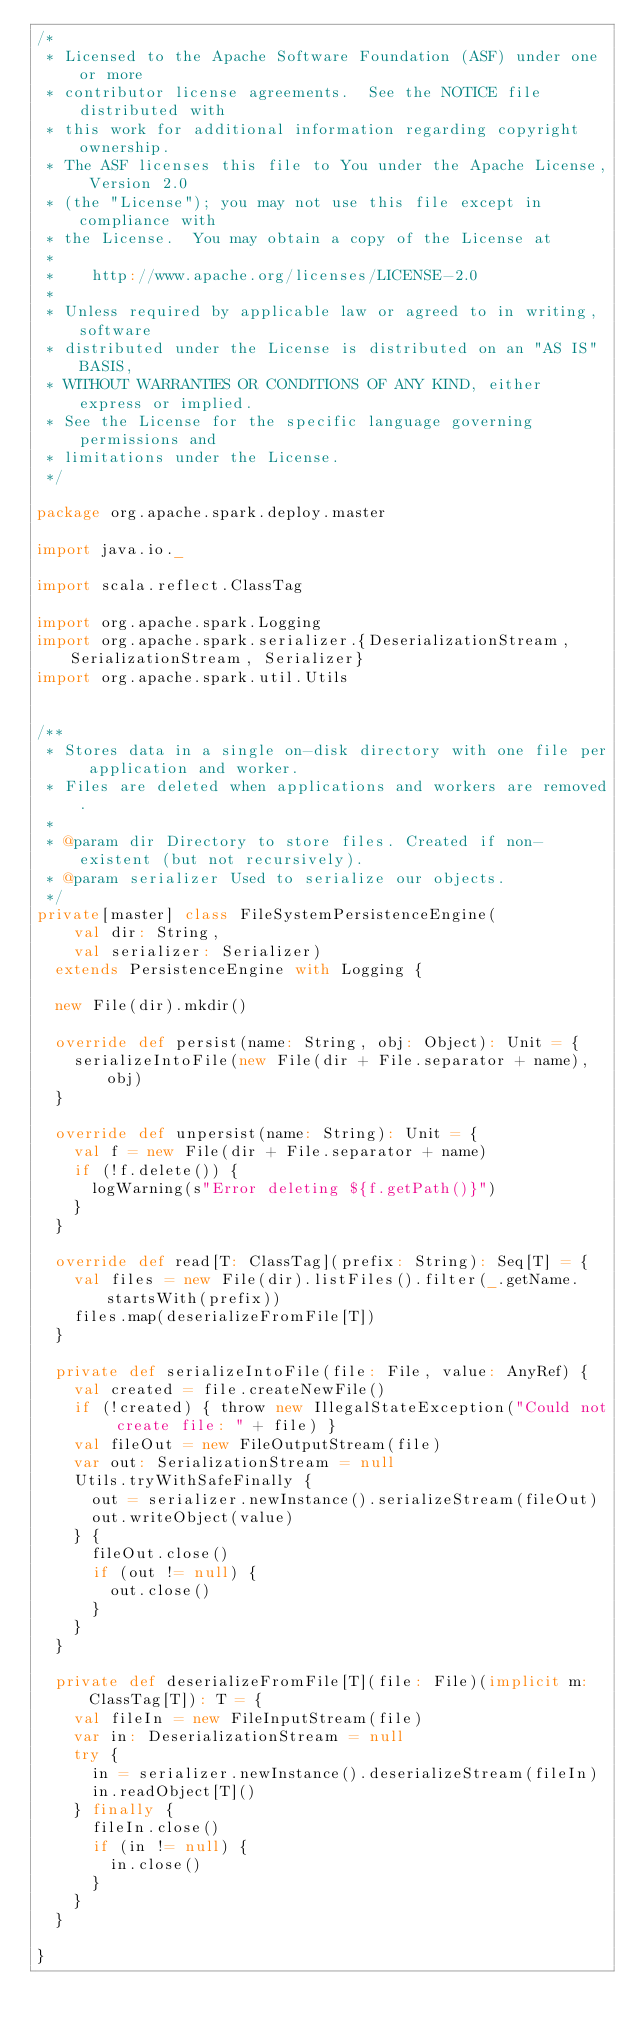Convert code to text. <code><loc_0><loc_0><loc_500><loc_500><_Scala_>/*
 * Licensed to the Apache Software Foundation (ASF) under one or more
 * contributor license agreements.  See the NOTICE file distributed with
 * this work for additional information regarding copyright ownership.
 * The ASF licenses this file to You under the Apache License, Version 2.0
 * (the "License"); you may not use this file except in compliance with
 * the License.  You may obtain a copy of the License at
 *
 *    http://www.apache.org/licenses/LICENSE-2.0
 *
 * Unless required by applicable law or agreed to in writing, software
 * distributed under the License is distributed on an "AS IS" BASIS,
 * WITHOUT WARRANTIES OR CONDITIONS OF ANY KIND, either express or implied.
 * See the License for the specific language governing permissions and
 * limitations under the License.
 */

package org.apache.spark.deploy.master

import java.io._

import scala.reflect.ClassTag

import org.apache.spark.Logging
import org.apache.spark.serializer.{DeserializationStream, SerializationStream, Serializer}
import org.apache.spark.util.Utils


/**
 * Stores data in a single on-disk directory with one file per application and worker.
 * Files are deleted when applications and workers are removed.
 *
 * @param dir Directory to store files. Created if non-existent (but not recursively).
 * @param serializer Used to serialize our objects.
 */
private[master] class FileSystemPersistenceEngine(
    val dir: String,
    val serializer: Serializer)
  extends PersistenceEngine with Logging {

  new File(dir).mkdir()

  override def persist(name: String, obj: Object): Unit = {
    serializeIntoFile(new File(dir + File.separator + name), obj)
  }

  override def unpersist(name: String): Unit = {
    val f = new File(dir + File.separator + name)
    if (!f.delete()) {
      logWarning(s"Error deleting ${f.getPath()}")
    }
  }

  override def read[T: ClassTag](prefix: String): Seq[T] = {
    val files = new File(dir).listFiles().filter(_.getName.startsWith(prefix))
    files.map(deserializeFromFile[T])
  }

  private def serializeIntoFile(file: File, value: AnyRef) {
    val created = file.createNewFile()
    if (!created) { throw new IllegalStateException("Could not create file: " + file) }
    val fileOut = new FileOutputStream(file)
    var out: SerializationStream = null
    Utils.tryWithSafeFinally {
      out = serializer.newInstance().serializeStream(fileOut)
      out.writeObject(value)
    } {
      fileOut.close()
      if (out != null) {
        out.close()
      }
    }
  }

  private def deserializeFromFile[T](file: File)(implicit m: ClassTag[T]): T = {
    val fileIn = new FileInputStream(file)
    var in: DeserializationStream = null
    try {
      in = serializer.newInstance().deserializeStream(fileIn)
      in.readObject[T]()
    } finally {
      fileIn.close()
      if (in != null) {
        in.close()
      }
    }
  }

}
</code> 